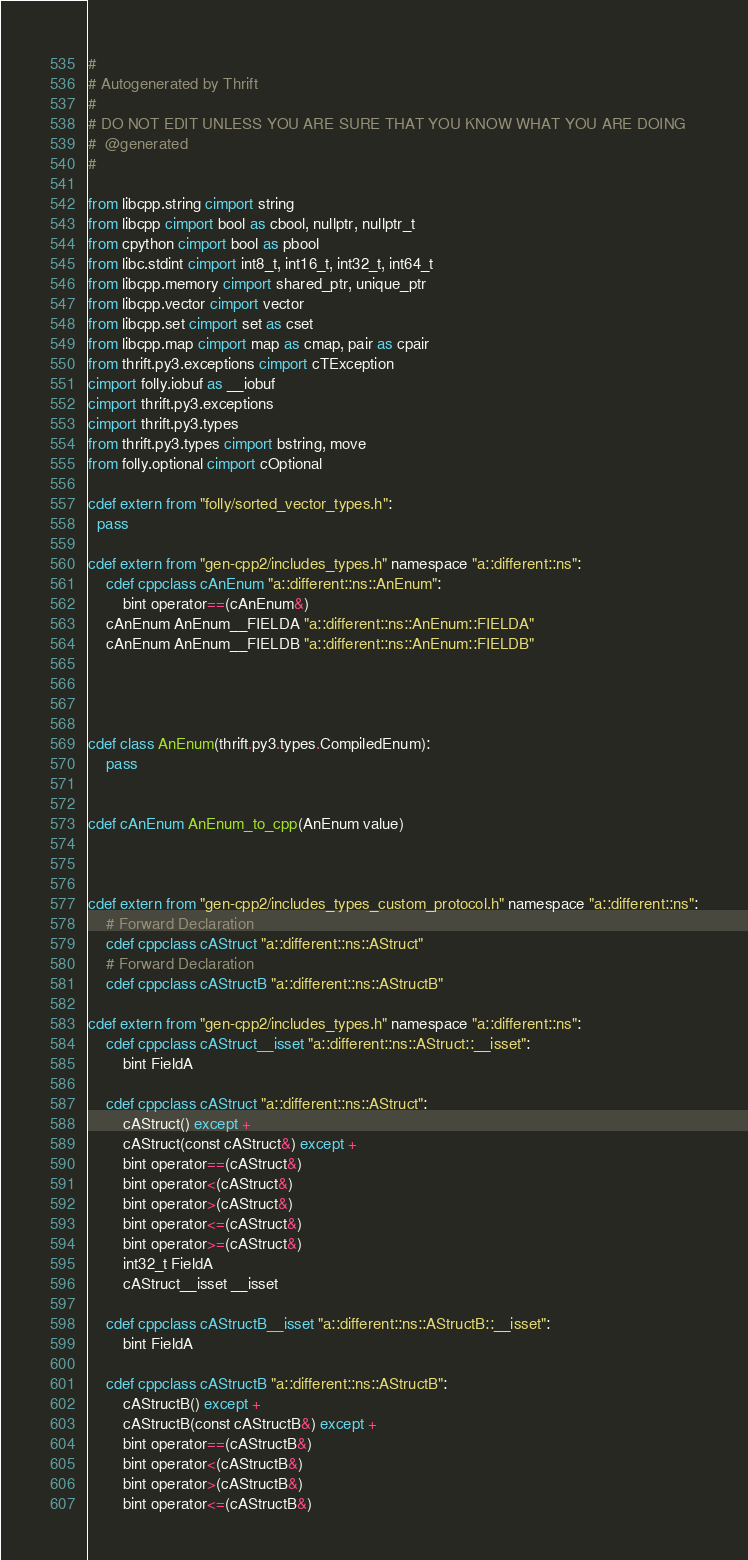Convert code to text. <code><loc_0><loc_0><loc_500><loc_500><_Cython_>#
# Autogenerated by Thrift
#
# DO NOT EDIT UNLESS YOU ARE SURE THAT YOU KNOW WHAT YOU ARE DOING
#  @generated
#

from libcpp.string cimport string
from libcpp cimport bool as cbool, nullptr, nullptr_t
from cpython cimport bool as pbool
from libc.stdint cimport int8_t, int16_t, int32_t, int64_t
from libcpp.memory cimport shared_ptr, unique_ptr
from libcpp.vector cimport vector
from libcpp.set cimport set as cset
from libcpp.map cimport map as cmap, pair as cpair
from thrift.py3.exceptions cimport cTException
cimport folly.iobuf as __iobuf
cimport thrift.py3.exceptions
cimport thrift.py3.types
from thrift.py3.types cimport bstring, move
from folly.optional cimport cOptional

cdef extern from "folly/sorted_vector_types.h":
  pass

cdef extern from "gen-cpp2/includes_types.h" namespace "a::different::ns":
    cdef cppclass cAnEnum "a::different::ns::AnEnum":
        bint operator==(cAnEnum&)
    cAnEnum AnEnum__FIELDA "a::different::ns::AnEnum::FIELDA"
    cAnEnum AnEnum__FIELDB "a::different::ns::AnEnum::FIELDB"




cdef class AnEnum(thrift.py3.types.CompiledEnum):
    pass


cdef cAnEnum AnEnum_to_cpp(AnEnum value)



cdef extern from "gen-cpp2/includes_types_custom_protocol.h" namespace "a::different::ns":
    # Forward Declaration
    cdef cppclass cAStruct "a::different::ns::AStruct"
    # Forward Declaration
    cdef cppclass cAStructB "a::different::ns::AStructB"

cdef extern from "gen-cpp2/includes_types.h" namespace "a::different::ns":
    cdef cppclass cAStruct__isset "a::different::ns::AStruct::__isset":
        bint FieldA

    cdef cppclass cAStruct "a::different::ns::AStruct":
        cAStruct() except +
        cAStruct(const cAStruct&) except +
        bint operator==(cAStruct&)
        bint operator<(cAStruct&)
        bint operator>(cAStruct&)
        bint operator<=(cAStruct&)
        bint operator>=(cAStruct&)
        int32_t FieldA
        cAStruct__isset __isset

    cdef cppclass cAStructB__isset "a::different::ns::AStructB::__isset":
        bint FieldA

    cdef cppclass cAStructB "a::different::ns::AStructB":
        cAStructB() except +
        cAStructB(const cAStructB&) except +
        bint operator==(cAStructB&)
        bint operator<(cAStructB&)
        bint operator>(cAStructB&)
        bint operator<=(cAStructB&)</code> 